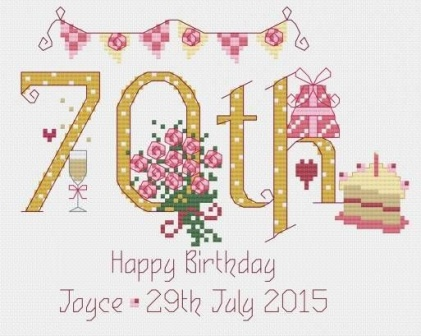How does the design style of the image contribute to the overall feel of the celebration? The design style of the image, resembling a cross-stitch pattern, adds a distinctively nostalgic and personalized touch to the celebration's depiction. The meticulous nature of cross-stitching, an art form known for its precision and dedication, mirrors the care and thought put into celebrating such a significant event. This stylistic choice conveys a sense of warmth and intimacy, suggesting that the birthday celebration is not just a formality but a heartfelt homage to the individual's life and achievements. 